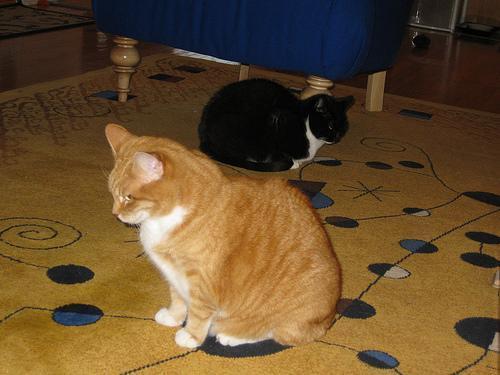How many animals are there?
Give a very brief answer. 2. 